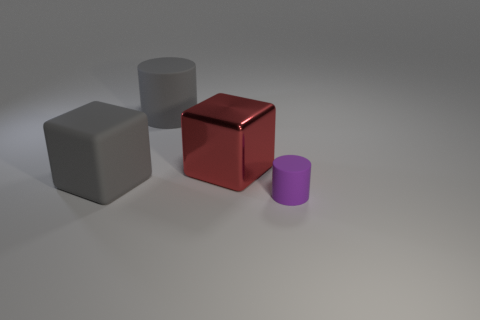Add 4 big matte blocks. How many objects exist? 8 Add 3 tiny purple rubber objects. How many tiny purple rubber objects exist? 4 Subtract 1 purple cylinders. How many objects are left? 3 Subtract all tiny green shiny things. Subtract all gray things. How many objects are left? 2 Add 1 large gray rubber cubes. How many large gray rubber cubes are left? 2 